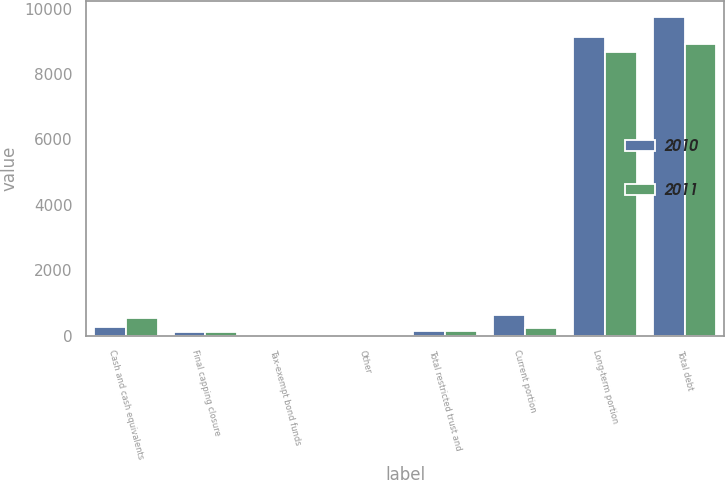Convert chart. <chart><loc_0><loc_0><loc_500><loc_500><stacked_bar_chart><ecel><fcel>Cash and cash equivalents<fcel>Final capping closure<fcel>Tax-exempt bond funds<fcel>Other<fcel>Total restricted trust and<fcel>Current portion<fcel>Long-term portion<fcel>Total debt<nl><fcel>2010<fcel>258<fcel>123<fcel>14<fcel>15<fcel>152<fcel>631<fcel>9125<fcel>9756<nl><fcel>2011<fcel>539<fcel>124<fcel>14<fcel>8<fcel>146<fcel>233<fcel>8674<fcel>8907<nl></chart> 